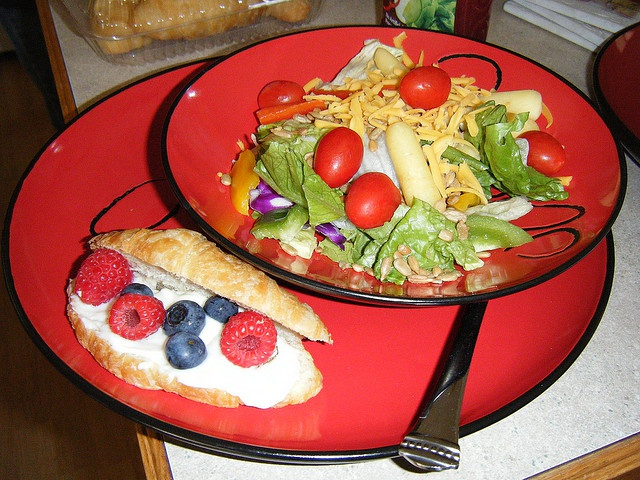Describe the objects in this image and their specific colors. I can see bowl in black, red, brown, khaki, and olive tones, sandwich in black, white, tan, and salmon tones, spoon in black, maroon, darkgreen, and gray tones, carrot in black, orange, red, and brown tones, and carrot in black, red, brown, and salmon tones in this image. 